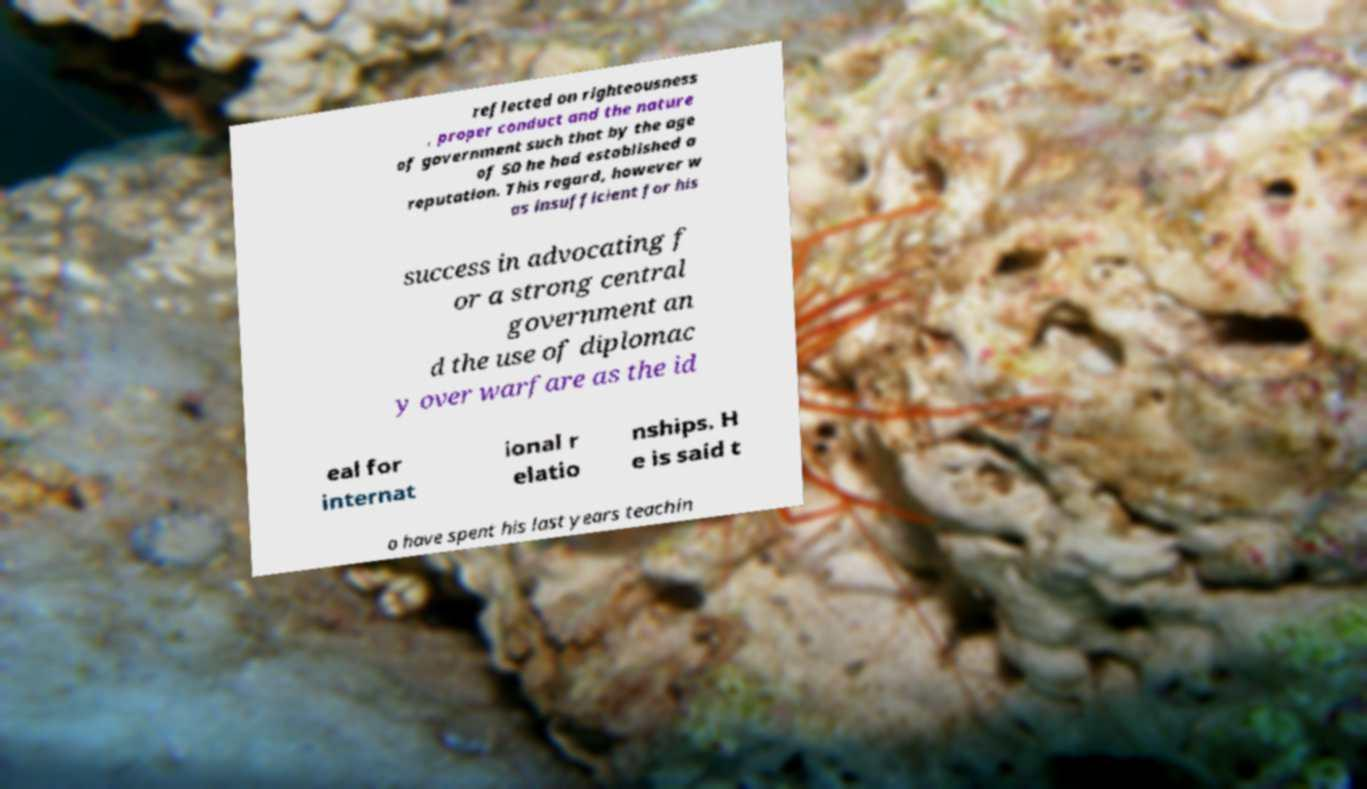Can you accurately transcribe the text from the provided image for me? reflected on righteousness , proper conduct and the nature of government such that by the age of 50 he had established a reputation. This regard, however w as insufficient for his success in advocating f or a strong central government an d the use of diplomac y over warfare as the id eal for internat ional r elatio nships. H e is said t o have spent his last years teachin 